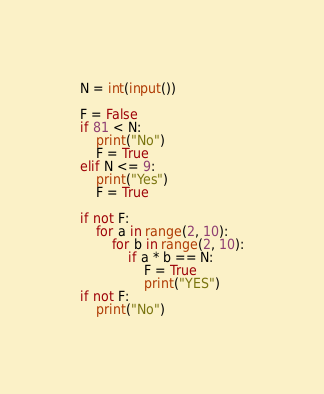<code> <loc_0><loc_0><loc_500><loc_500><_Python_>N = int(input())

F = False
if 81 < N:
    print("No")
    F = True
elif N <= 9:
    print("Yes")
    F = True

if not F:
    for a in range(2, 10):
        for b in range(2, 10):
            if a * b == N:
                F = True
                print("YES")
if not F:
    print("No")</code> 